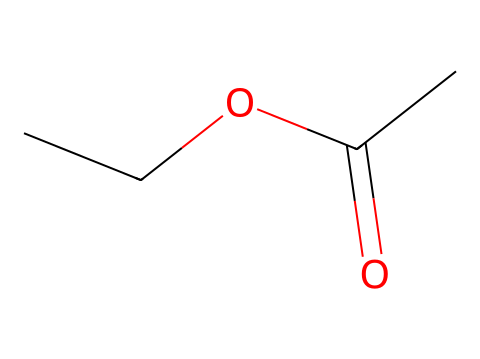What is the chemical name of this molecule? The SMILES representation indicates an ester functional group with an ethyl group and an acetate moiety, which corresponds to ethyl acetate.
Answer: ethyl acetate How many carbon atoms are in ethyl acetate? By analyzing the structure, there are two carbon atoms from the ethyl group (C2) and one carbon from the acetate moiety (C1), totaling three carbon atoms.
Answer: three What type of functional group does this molecule contain? The molecule contains a carbonyl group (C=O) and an alcohol part (C-O), characteristic of esters, making it specifically an ester functional group.
Answer: ester What is the total number of hydrogen atoms in ethyl acetate? The ethyl group contributes five hydrogen atoms (C2H5), and the acetate group contributes three hydrogen atoms (C1O2H3), resulting in a total of eight hydrogen atoms.
Answer: eight Does ethyl acetate have a fruity aroma? Esters, including ethyl acetate, are known for their fruity smells, often reminiscent of fruits, making this compound aromatic and characteristic of many beers.
Answer: yes What is the significance of ethyl acetate in beer production? Ethyl acetate is important in beer as it contributes to the pleasant fruity aroma, enhancing the sensory experience.
Answer: aroma contribution 